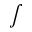Convert formula to latex. <formula><loc_0><loc_0><loc_500><loc_500>\int</formula> 